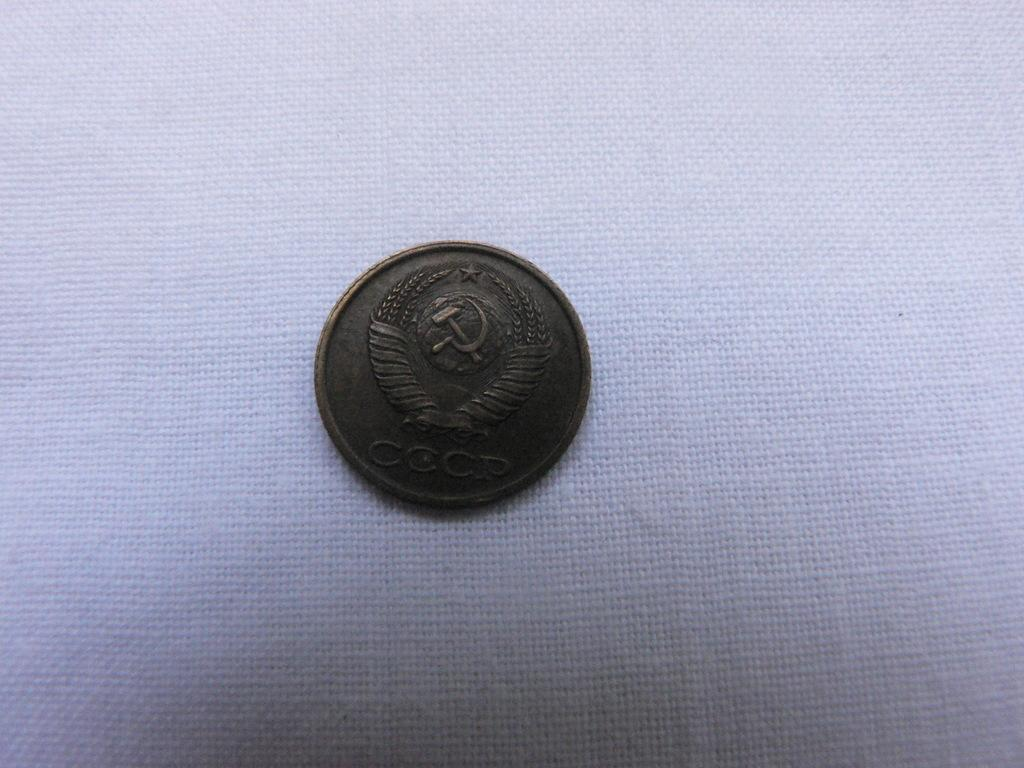<image>
Relay a brief, clear account of the picture shown. a bronze coin that says 'cccp' on the bottom of it 